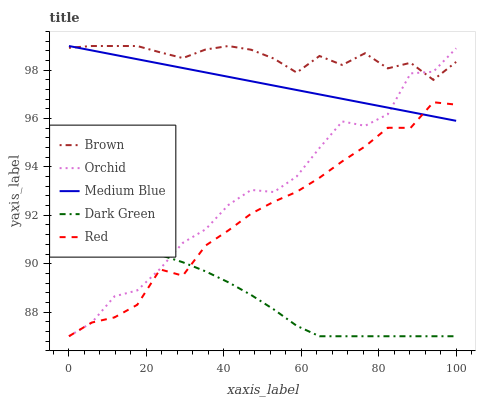Does Dark Green have the minimum area under the curve?
Answer yes or no. Yes. Does Brown have the maximum area under the curve?
Answer yes or no. Yes. Does Medium Blue have the minimum area under the curve?
Answer yes or no. No. Does Medium Blue have the maximum area under the curve?
Answer yes or no. No. Is Medium Blue the smoothest?
Answer yes or no. Yes. Is Orchid the roughest?
Answer yes or no. Yes. Is Dark Green the smoothest?
Answer yes or no. No. Is Dark Green the roughest?
Answer yes or no. No. Does Dark Green have the lowest value?
Answer yes or no. Yes. Does Medium Blue have the lowest value?
Answer yes or no. No. Does Medium Blue have the highest value?
Answer yes or no. Yes. Does Dark Green have the highest value?
Answer yes or no. No. Is Dark Green less than Medium Blue?
Answer yes or no. Yes. Is Brown greater than Dark Green?
Answer yes or no. Yes. Does Medium Blue intersect Orchid?
Answer yes or no. Yes. Is Medium Blue less than Orchid?
Answer yes or no. No. Is Medium Blue greater than Orchid?
Answer yes or no. No. Does Dark Green intersect Medium Blue?
Answer yes or no. No. 